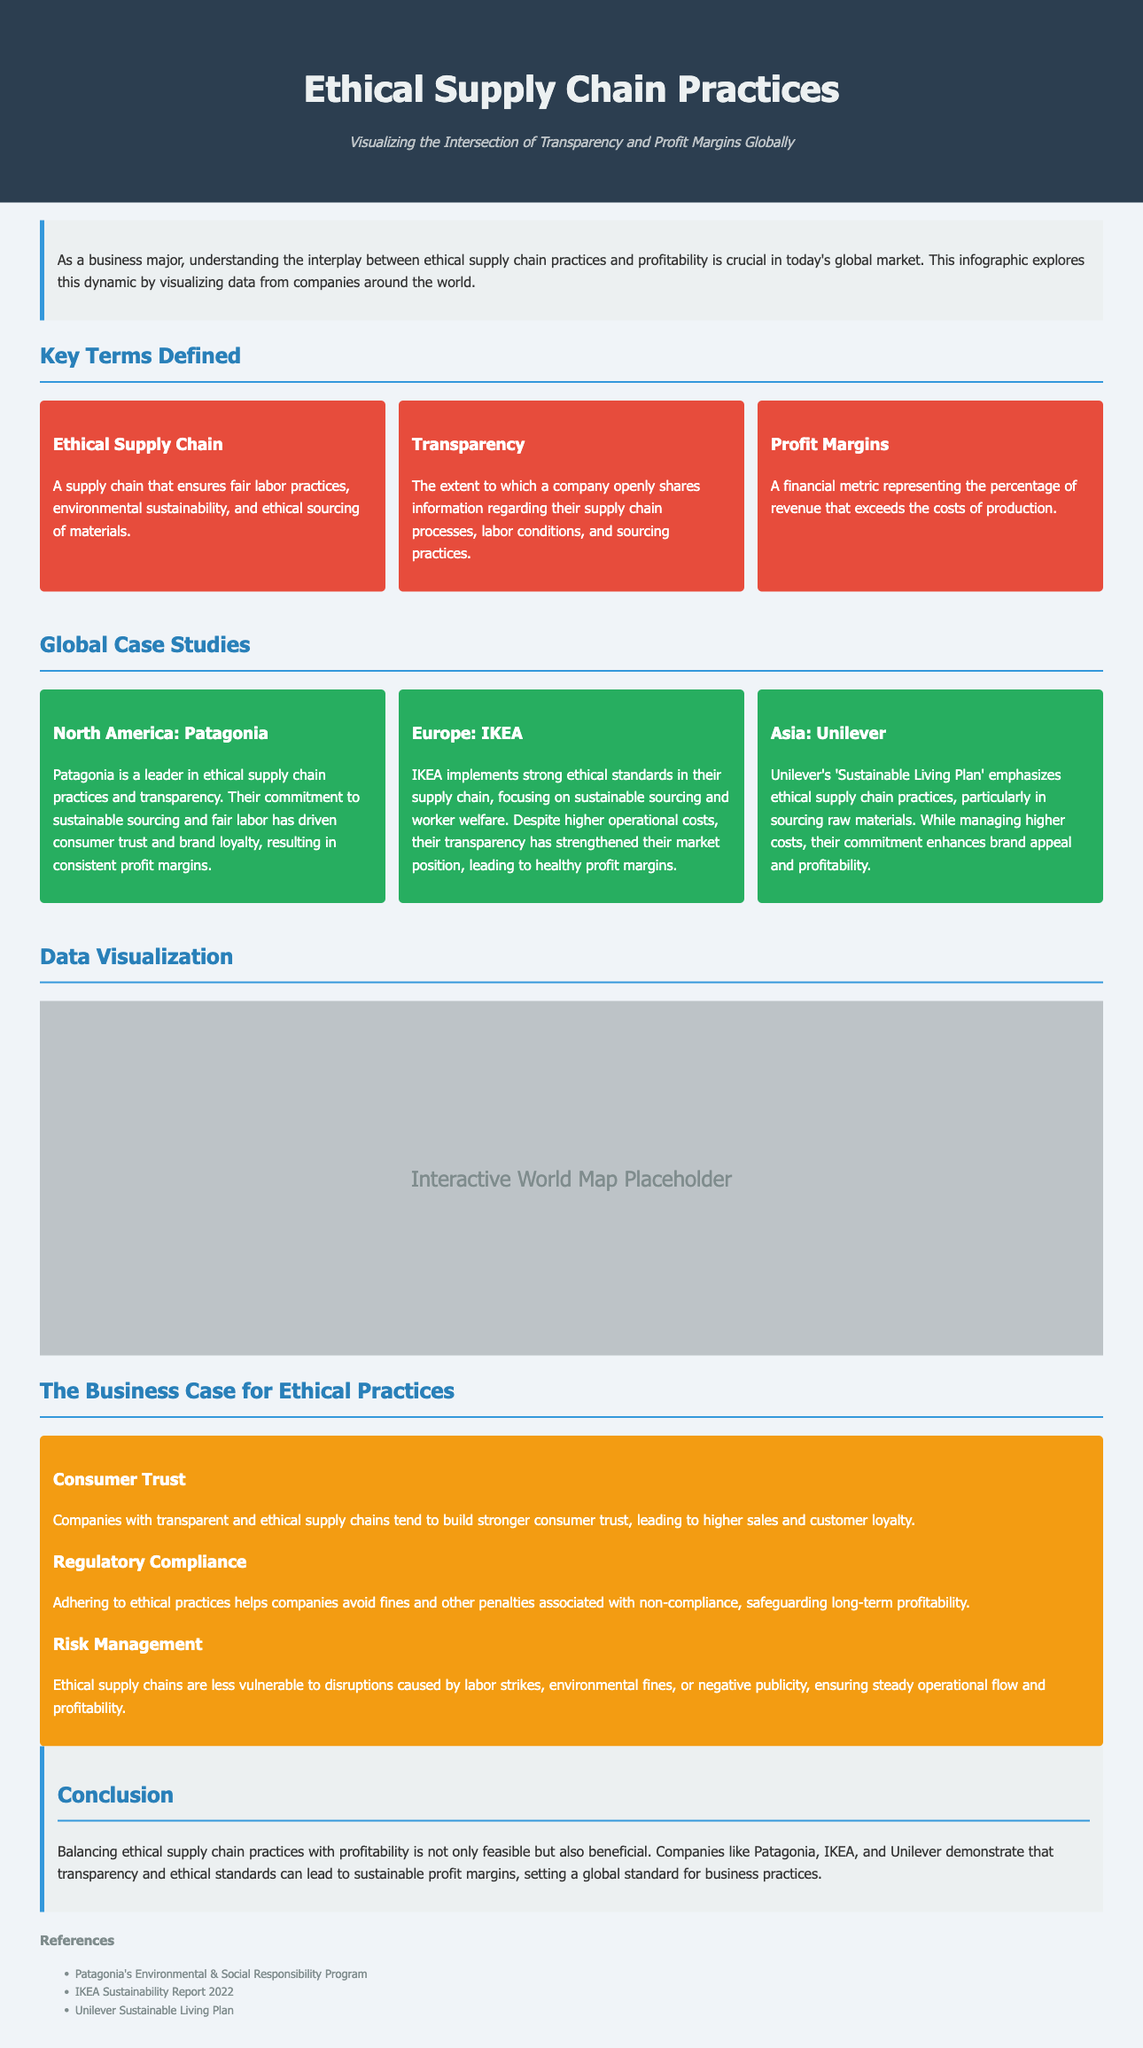what is the title of the infographic? The title of the infographic is explicitly stated at the top of the document.
Answer: Ethical Supply Chain Practices: Visualizing the Intersection of Transparency and Profit Margins Globally who is highlighted as a leader in ethical supply chain practices in North America? The document specifically references Patagonia as a leader in ethical supply chain practices in North America.
Answer: Patagonia what is the subtitle of the infographic? The subtitle provides additional context about the infographic's focus, found beneath the title.
Answer: Visualizing the Intersection of Transparency and Profit Margins Globally which company is mentioned in the case study for Europe? The case study focusing on Europe highlights a well-known company that has implemented ethical standards in its supply chain.
Answer: IKEA what is one key benefit of ethical supply chain practices mentioned in the business case section? The benefits are outlined in the business case section and require identification of a specific advantage.
Answer: Consumer Trust what does "Profit Margins" refer to in the document? The document provides a definition for "Profit Margins," specifying what the term signifies in a business context.
Answer: A financial metric representing the percentage of revenue that exceeds the costs of production how does Unilever's commitment to ethical supply chain practices affect its profitability according to the case study? The case study on Unilever discusses its approach and the relationship between ethical practices and financial success.
Answer: Enhances brand appeal and profitability what is shown in the map container of the infographic? The description of this section suggests its intended purpose in the infographic.
Answer: Interactive World Map Placeholder 